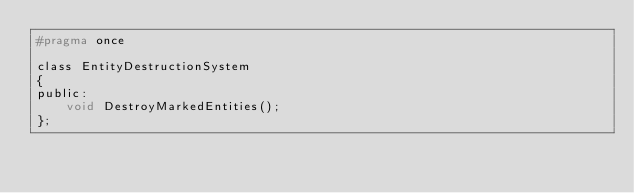Convert code to text. <code><loc_0><loc_0><loc_500><loc_500><_C_>#pragma once

class EntityDestructionSystem
{
public:
	void DestroyMarkedEntities();
};

</code> 